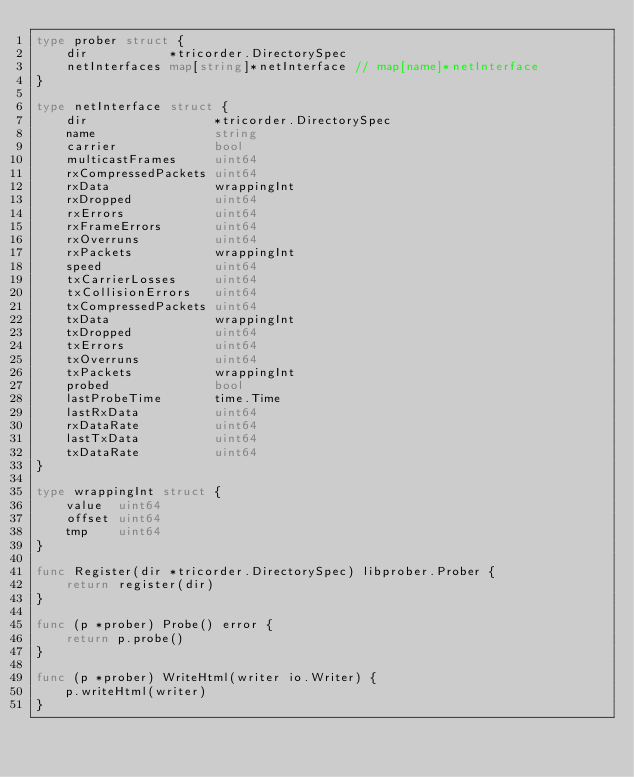Convert code to text. <code><loc_0><loc_0><loc_500><loc_500><_Go_>type prober struct {
	dir           *tricorder.DirectorySpec
	netInterfaces map[string]*netInterface // map[name]*netInterface
}

type netInterface struct {
	dir                 *tricorder.DirectorySpec
	name                string
	carrier             bool
	multicastFrames     uint64
	rxCompressedPackets uint64
	rxData              wrappingInt
	rxDropped           uint64
	rxErrors            uint64
	rxFrameErrors       uint64
	rxOverruns          uint64
	rxPackets           wrappingInt
	speed               uint64
	txCarrierLosses     uint64
	txCollisionErrors   uint64
	txCompressedPackets uint64
	txData              wrappingInt
	txDropped           uint64
	txErrors            uint64
	txOverruns          uint64
	txPackets           wrappingInt
	probed              bool
	lastProbeTime       time.Time
	lastRxData          uint64
	rxDataRate          uint64
	lastTxData          uint64
	txDataRate          uint64
}

type wrappingInt struct {
	value  uint64
	offset uint64
	tmp    uint64
}

func Register(dir *tricorder.DirectorySpec) libprober.Prober {
	return register(dir)
}

func (p *prober) Probe() error {
	return p.probe()
}

func (p *prober) WriteHtml(writer io.Writer) {
	p.writeHtml(writer)
}
</code> 